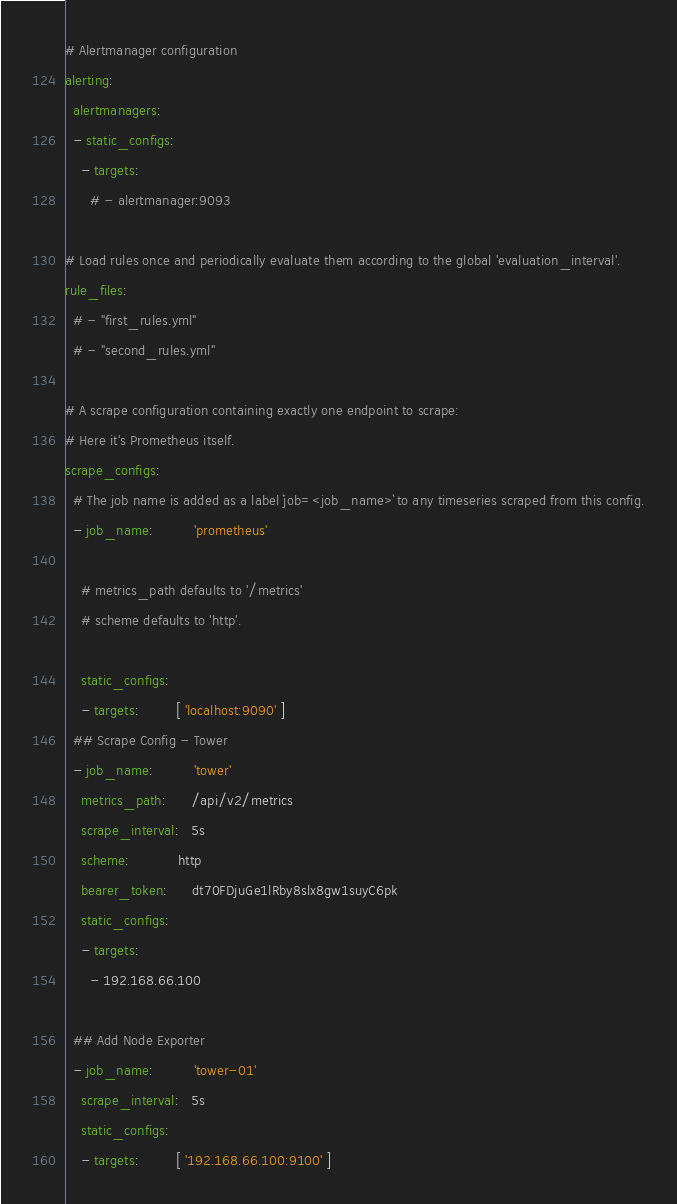Convert code to text. <code><loc_0><loc_0><loc_500><loc_500><_YAML_>
# Alertmanager configuration
alerting:
  alertmanagers:
  - static_configs:
    - targets:
      # - alertmanager:9093

# Load rules once and periodically evaluate them according to the global 'evaluation_interval'.
rule_files:
  # - "first_rules.yml"
  # - "second_rules.yml"

# A scrape configuration containing exactly one endpoint to scrape:
# Here it's Prometheus itself.
scrape_configs:
  # The job name is added as a label `job=<job_name>` to any timeseries scraped from this config.
  - job_name:          'prometheus'

    # metrics_path defaults to '/metrics'
    # scheme defaults to 'http'.

    static_configs:
    - targets:         [ 'localhost:9090' ]
  ## Scrape Config - Tower
  - job_name:          'tower'
    metrics_path:      /api/v2/metrics
    scrape_interval:   5s
    scheme:            http
    bearer_token:      dt70FDjuGe1lRby8slx8gw1suyC6pk
    static_configs:
    - targets:
      - 192.168.66.100

  ## Add Node Exporter
  - job_name:          'tower-01'
    scrape_interval:   5s
    static_configs:
    - targets:         [ '192.168.66.100:9100' ]
</code> 